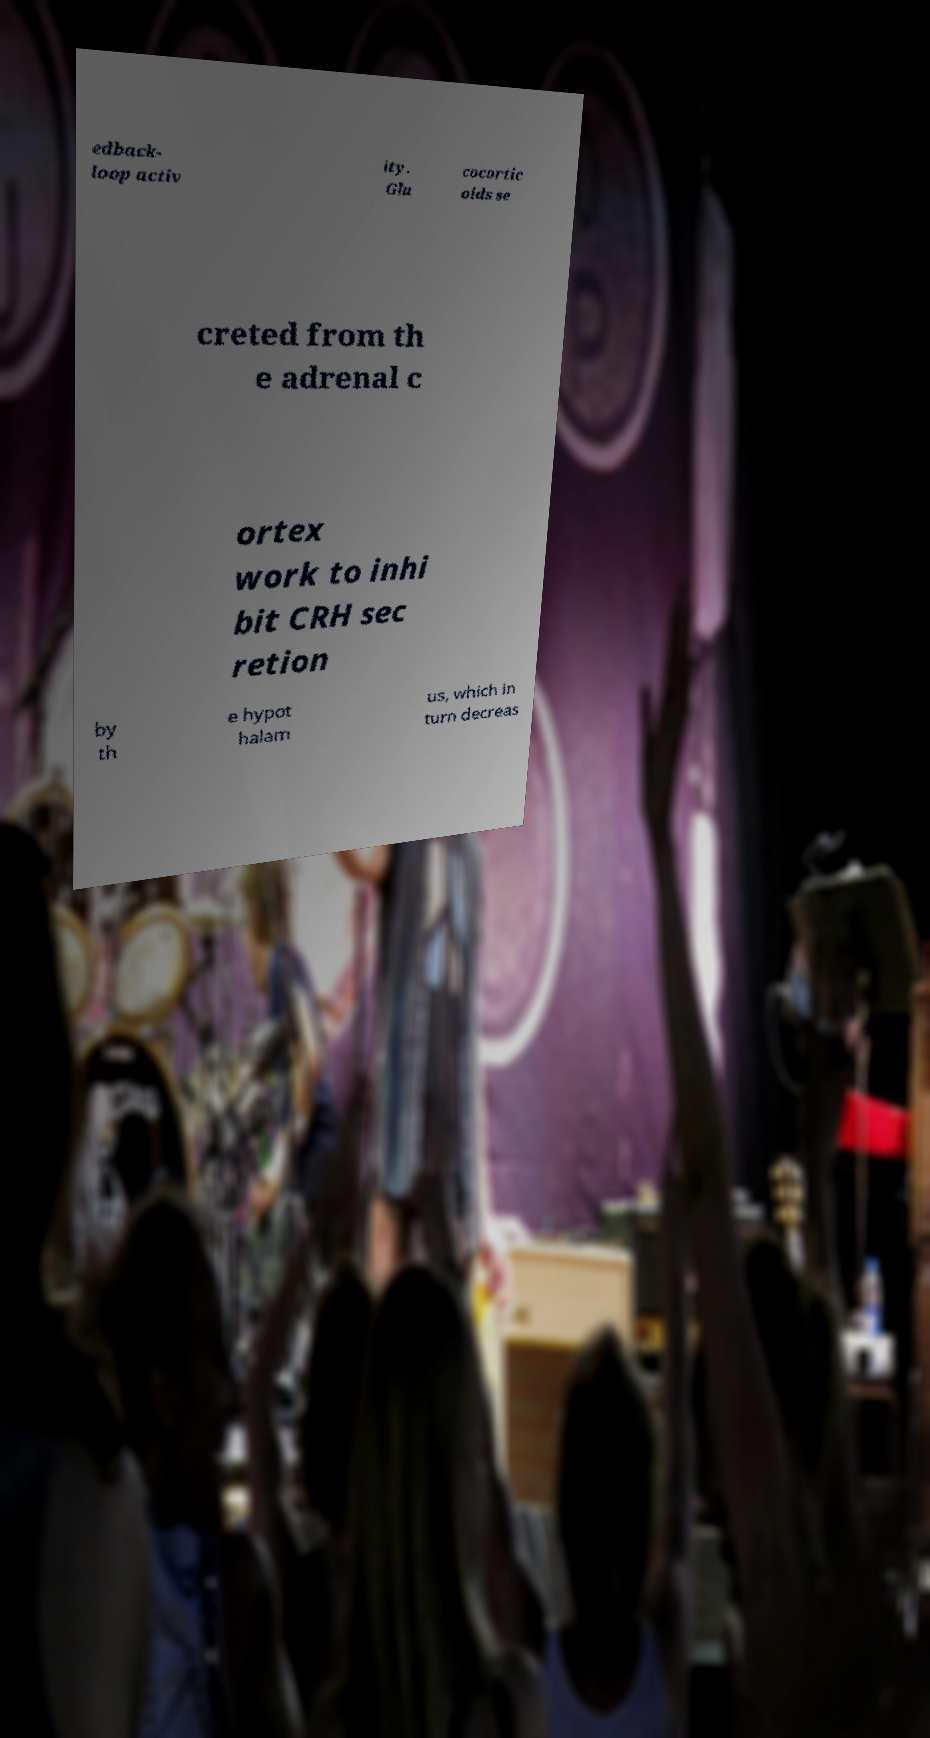Please read and relay the text visible in this image. What does it say? edback- loop activ ity. Glu cocortic oids se creted from th e adrenal c ortex work to inhi bit CRH sec retion by th e hypot halam us, which in turn decreas 